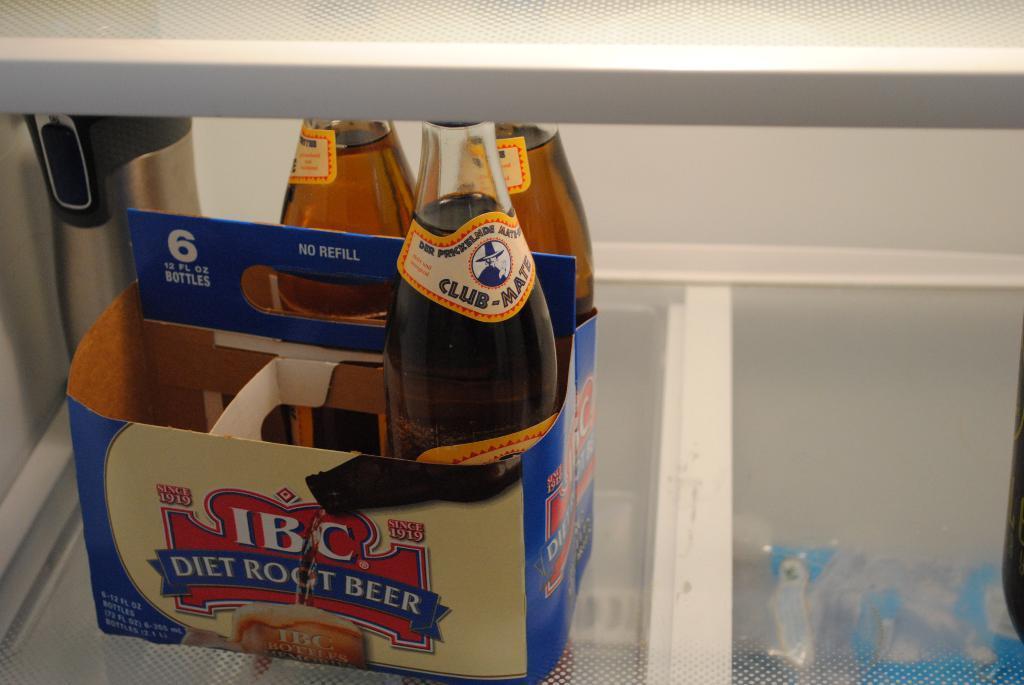Please provide a concise description of this image. This is a box with 3 wine bottles in it. 